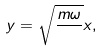Convert formula to latex. <formula><loc_0><loc_0><loc_500><loc_500>y = \sqrt { \frac { m \omega } { } } x ,</formula> 